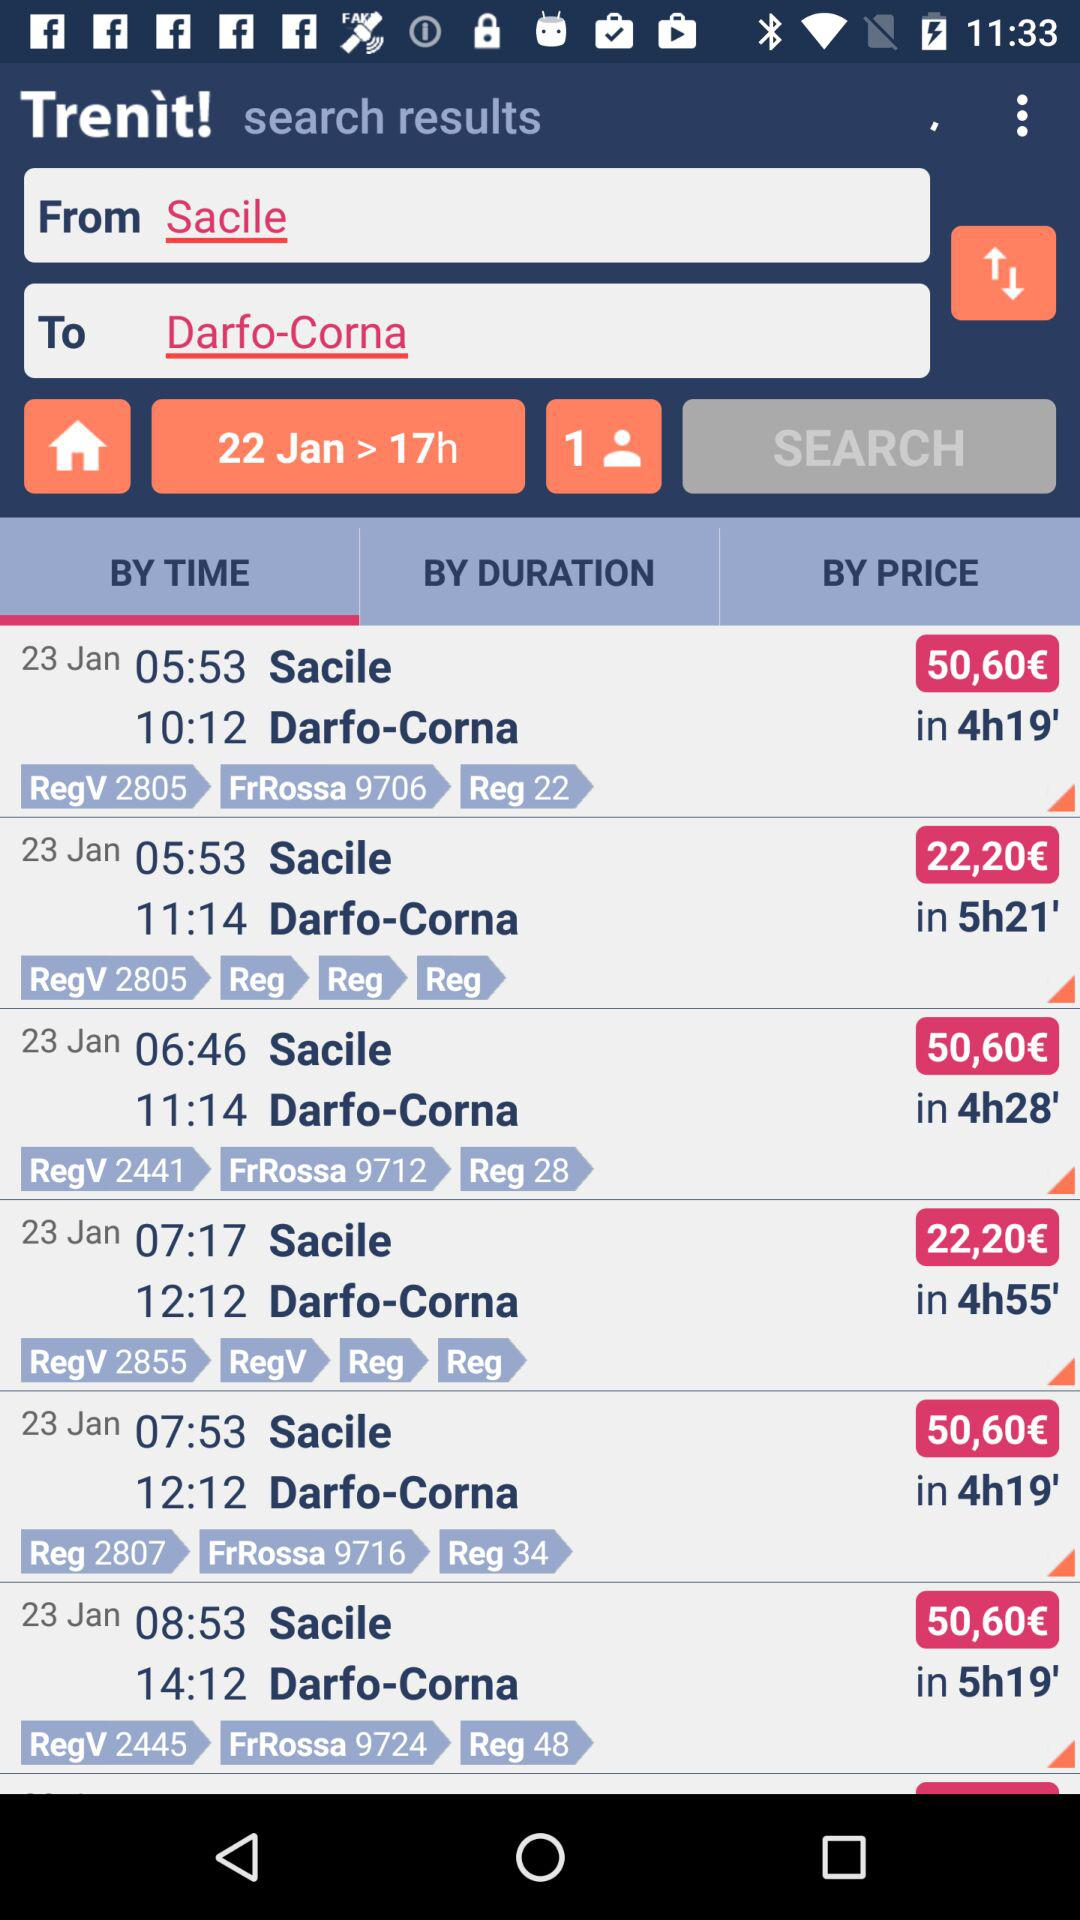What are the different arrival and departure times? The different arrival and departure times are: 05:53 and 10:12, 05:53 and 11:14, 06:46 and 11:14, 07:17 and 12:12, 07:53 and 12:12, and 08:53 and 14:12. 